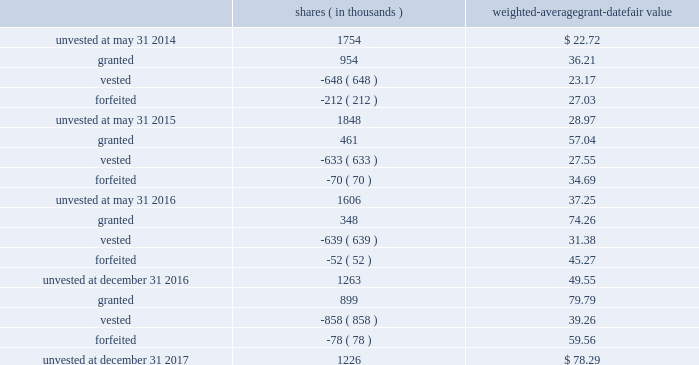Leveraged performance units during the year ended may 31 , 2015 , certain executives were granted performance units that we refer to as 201cleveraged performance units , 201d or 201clpus . 201d lpus contain a market condition based on our relative stock price growth over a three-year performance period .
The lpus contain a minimum threshold performance which , if not met , would result in no payout .
The lpus also contain a maximum award opportunity set as a fixed dollar and fixed number of shares .
After the three-year performance period , which concluded in october 2017 , one-third of the earned units converted to unrestricted common stock .
The remaining two-thirds converted to restricted stock that will vest in equal installments on each of the first two anniversaries of the conversion date .
We recognize share-based compensation expense based on the grant date fair value of the lpus , as determined by use of a monte carlo model , on a straight-line basis over the requisite service period for each separately vesting portion of the lpu award .
The table summarizes the changes in unvested restricted stock and performance awards for the year ended december 31 , 2017 , the 2016 fiscal transition period and for the years ended may 31 , 2016 and 2015 : shares weighted-average grant-date fair value ( in thousands ) .
The total fair value of restricted stock and performance awards vested was $ 33.7 million for the year ended december 31 , 2017 , $ 20.0 million for the 2016 fiscal transition period and $ 17.4 million and $ 15.0 million , respectively , for the years ended may 31 , 2016 and 2015 .
For restricted stock and performance awards , we recognized compensation expense of $ 35.2 million for the year ended december 31 , 2017 , $ 17.2 million for the 2016 fiscal transition period and $ 28.8 million and $ 19.8 million , respectively , for the years ended may 31 , 2016 and 2015 .
As of december 31 , 2017 , there was $ 46.1 million of unrecognized compensation expense related to unvested restricted stock and performance awards that we expect to recognize over a weighted-average period of 1.8 years .
Our restricted stock and performance award plans provide for accelerated vesting under certain conditions .
Stock options stock options are granted with an exercise price equal to 100% ( 100 % ) of fair market value of our common stock on the date of grant and have a term of ten years .
Stock options granted before the year ended may 31 , 2015 vest in equal installments on each of the first four anniversaries of the grant date .
Stock options granted during the year ended may 31 , 2015 and thereafter vest in equal installments on each of the first three anniversaries of the grant date .
Our stock option plans provide for accelerated vesting under certain conditions .
Global payments inc .
| 2017 form 10-k annual report 2013 91 .
What was the change in millions in the total fair value of restricted stock and performance awards vested from 2016 to 2017? 
Computations: (33.7 - 20.0)
Answer: 13.7. 